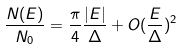<formula> <loc_0><loc_0><loc_500><loc_500>\frac { N ( E ) } { N _ { 0 } } = \frac { \pi } { 4 } \frac { | E | } { \Delta } + O ( \frac { E } { \Delta } ) ^ { 2 }</formula> 